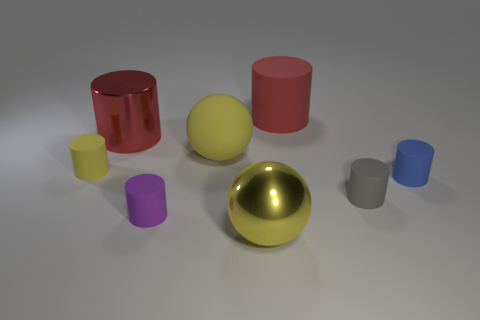Subtract all large metal cylinders. How many cylinders are left? 5 Subtract all red cylinders. How many cylinders are left? 4 Subtract 2 cylinders. How many cylinders are left? 4 Add 1 tiny purple cylinders. How many objects exist? 9 Subtract all purple spheres. How many purple cylinders are left? 1 Subtract all gray things. Subtract all red rubber things. How many objects are left? 6 Add 3 large matte things. How many large matte things are left? 5 Add 5 metal cylinders. How many metal cylinders exist? 6 Subtract 1 yellow balls. How many objects are left? 7 Subtract all cylinders. How many objects are left? 2 